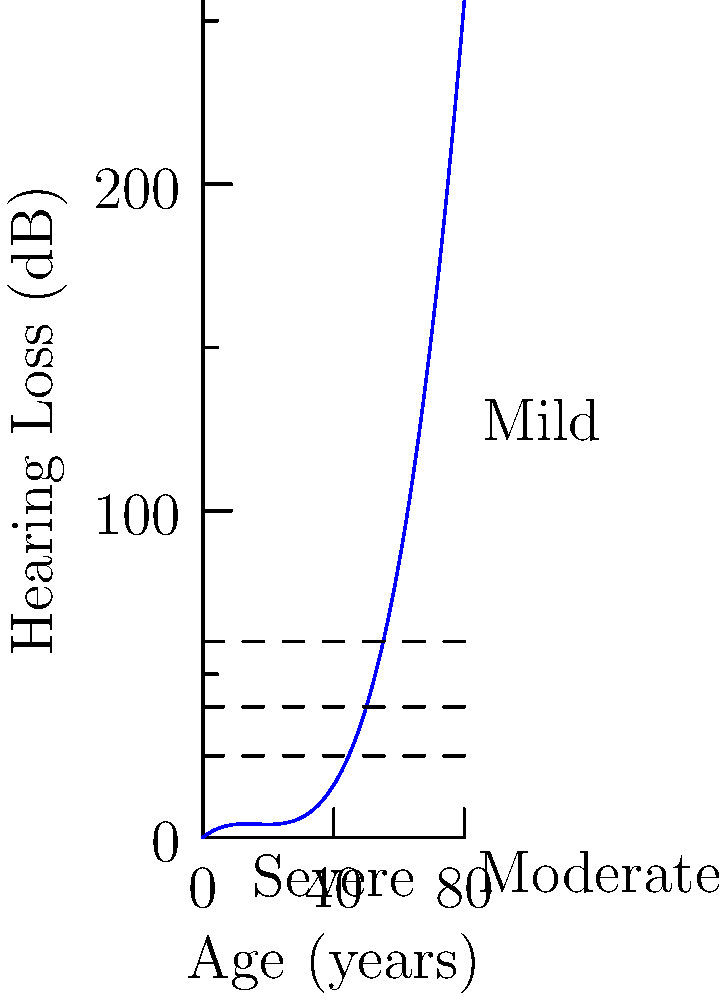Based on the polynomial graph showing the relationship between age and hearing loss progression, at approximately what age does the average person transition from mild to moderate hearing loss? To answer this question, we need to follow these steps:

1. Understand the hearing loss classification:
   - Mild hearing loss: 0-25 dB
   - Moderate hearing loss: 25-40 dB
   - Severe hearing loss: 40-60 dB

2. Identify the transition point:
   The transition from mild to moderate hearing loss occurs at 25 dB.

3. Locate the intersection:
   Find where the curve intersects the 25 dB horizontal line.

4. Estimate the age:
   The intersection occurs at approximately 45 years on the x-axis.

5. Interpret the result:
   This means that, on average, a person transitions from mild to moderate hearing loss at around 45 years of age.

It's important to note that this is a general trend, and individual cases may vary due to factors such as genetics, noise exposure, and overall health.
Answer: 45 years 